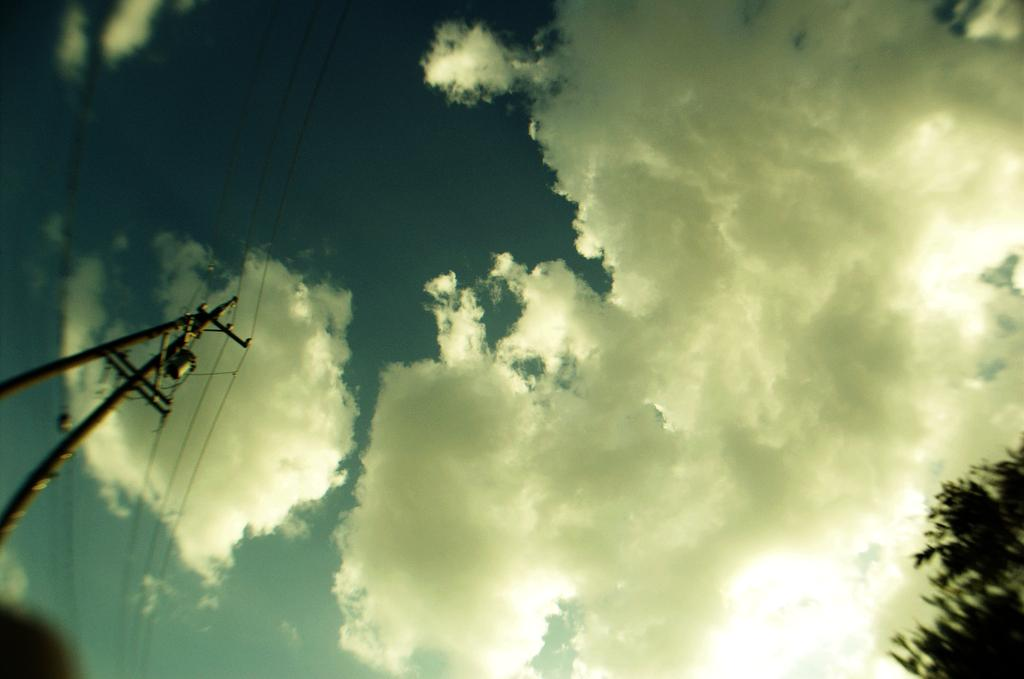What can be seen on the left side of the image? There are poles with electrical lines on the left side of the image. What is located on the right side of the image? There are trees on the right side of the image. What is visible in the background of the image? There are clouds in the sky in the background of the image. What grade level is being taught in the image? There is no indication of a grade level or teaching in the image; it features poles with electrical lines, trees, and clouds. How many boys are visible in the image? There are no boys present in the image. 